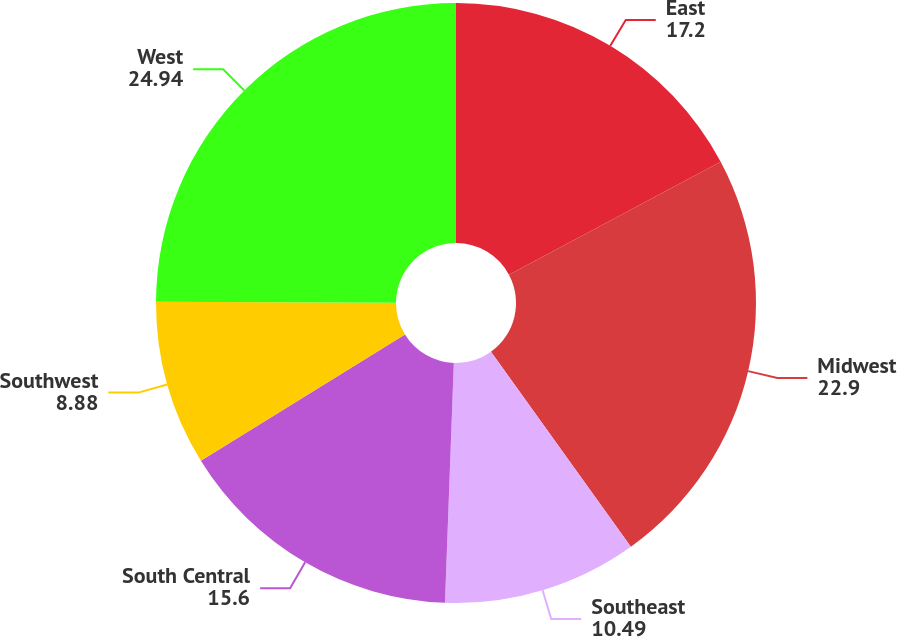Convert chart to OTSL. <chart><loc_0><loc_0><loc_500><loc_500><pie_chart><fcel>East<fcel>Midwest<fcel>Southeast<fcel>South Central<fcel>Southwest<fcel>West<nl><fcel>17.2%<fcel>22.9%<fcel>10.49%<fcel>15.6%<fcel>8.88%<fcel>24.94%<nl></chart> 